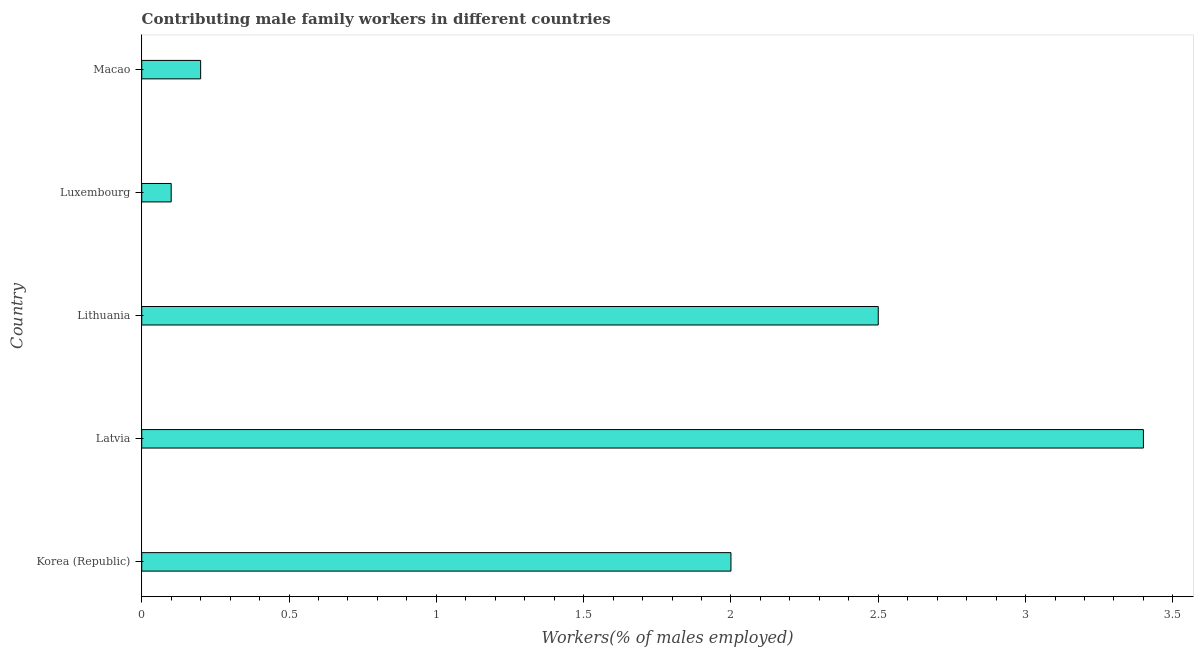Does the graph contain any zero values?
Offer a terse response. No. Does the graph contain grids?
Your answer should be compact. No. What is the title of the graph?
Offer a terse response. Contributing male family workers in different countries. What is the label or title of the X-axis?
Make the answer very short. Workers(% of males employed). What is the label or title of the Y-axis?
Keep it short and to the point. Country. What is the contributing male family workers in Macao?
Offer a terse response. 0.2. Across all countries, what is the maximum contributing male family workers?
Give a very brief answer. 3.4. Across all countries, what is the minimum contributing male family workers?
Give a very brief answer. 0.1. In which country was the contributing male family workers maximum?
Offer a terse response. Latvia. In which country was the contributing male family workers minimum?
Your response must be concise. Luxembourg. What is the sum of the contributing male family workers?
Your answer should be compact. 8.2. What is the difference between the contributing male family workers in Korea (Republic) and Lithuania?
Offer a terse response. -0.5. What is the average contributing male family workers per country?
Your answer should be very brief. 1.64. What is the median contributing male family workers?
Offer a very short reply. 2. In how many countries, is the contributing male family workers greater than 0.6 %?
Provide a succinct answer. 3. What is the ratio of the contributing male family workers in Latvia to that in Luxembourg?
Make the answer very short. 34. Is the difference between the contributing male family workers in Korea (Republic) and Luxembourg greater than the difference between any two countries?
Your response must be concise. No. What is the difference between the highest and the second highest contributing male family workers?
Keep it short and to the point. 0.9. Is the sum of the contributing male family workers in Latvia and Luxembourg greater than the maximum contributing male family workers across all countries?
Ensure brevity in your answer.  Yes. In how many countries, is the contributing male family workers greater than the average contributing male family workers taken over all countries?
Your answer should be compact. 3. How many bars are there?
Provide a short and direct response. 5. What is the difference between two consecutive major ticks on the X-axis?
Ensure brevity in your answer.  0.5. What is the Workers(% of males employed) of Korea (Republic)?
Offer a very short reply. 2. What is the Workers(% of males employed) in Latvia?
Provide a succinct answer. 3.4. What is the Workers(% of males employed) in Lithuania?
Offer a terse response. 2.5. What is the Workers(% of males employed) in Luxembourg?
Give a very brief answer. 0.1. What is the Workers(% of males employed) of Macao?
Offer a terse response. 0.2. What is the difference between the Workers(% of males employed) in Korea (Republic) and Latvia?
Ensure brevity in your answer.  -1.4. What is the difference between the Workers(% of males employed) in Korea (Republic) and Luxembourg?
Make the answer very short. 1.9. What is the difference between the Workers(% of males employed) in Korea (Republic) and Macao?
Give a very brief answer. 1.8. What is the difference between the Workers(% of males employed) in Latvia and Macao?
Ensure brevity in your answer.  3.2. What is the difference between the Workers(% of males employed) in Lithuania and Macao?
Your answer should be compact. 2.3. What is the difference between the Workers(% of males employed) in Luxembourg and Macao?
Your answer should be compact. -0.1. What is the ratio of the Workers(% of males employed) in Korea (Republic) to that in Latvia?
Ensure brevity in your answer.  0.59. What is the ratio of the Workers(% of males employed) in Latvia to that in Lithuania?
Give a very brief answer. 1.36. What is the ratio of the Workers(% of males employed) in Latvia to that in Luxembourg?
Your answer should be very brief. 34. What is the ratio of the Workers(% of males employed) in Lithuania to that in Macao?
Your answer should be very brief. 12.5. 